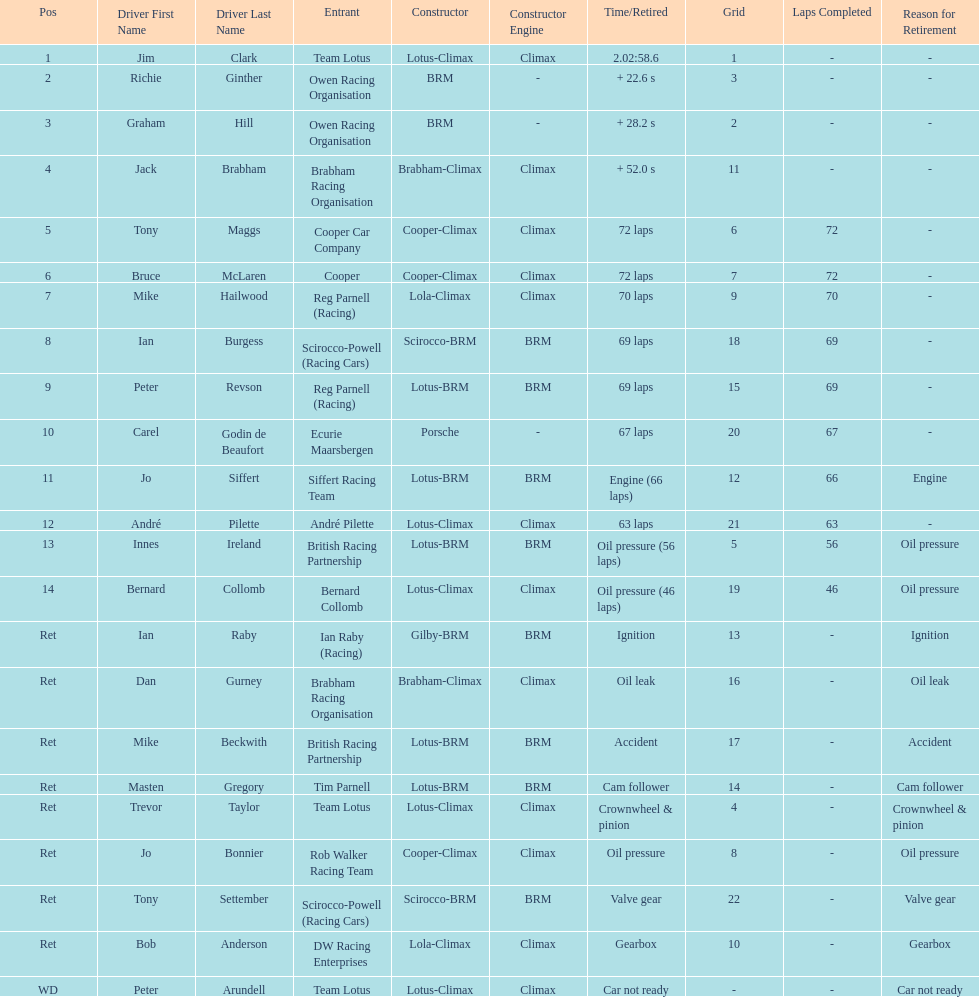Who was the top finisher that drove a cooper-climax? Tony Maggs. 